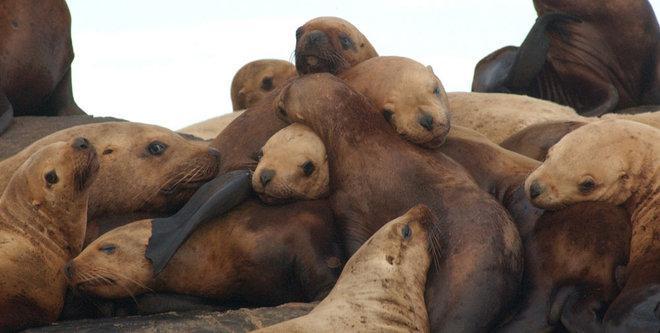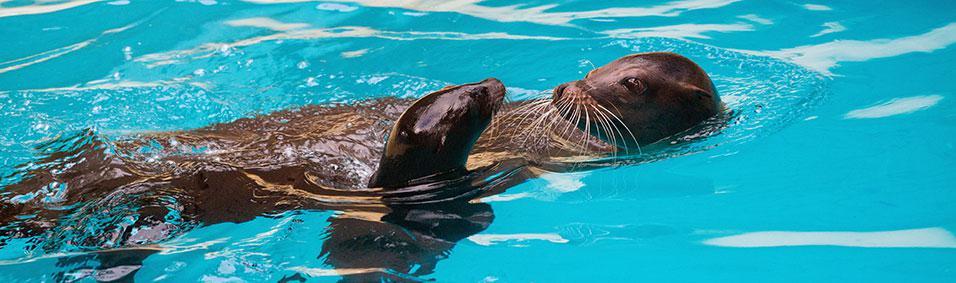The first image is the image on the left, the second image is the image on the right. Analyze the images presented: Is the assertion "There are more than ten sea lions in the images." valid? Answer yes or no. Yes. 